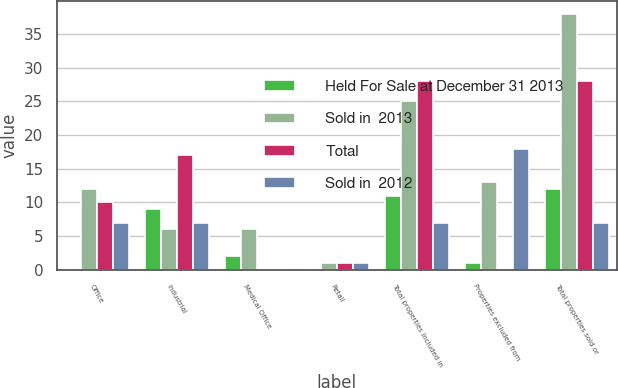Convert chart. <chart><loc_0><loc_0><loc_500><loc_500><stacked_bar_chart><ecel><fcel>Office<fcel>Industrial<fcel>Medical Office<fcel>Retail<fcel>Total properties included in<fcel>Properties excluded from<fcel>Total properties sold or<nl><fcel>Held For Sale at December 31 2013<fcel>0<fcel>9<fcel>2<fcel>0<fcel>11<fcel>1<fcel>12<nl><fcel>Sold in  2013<fcel>12<fcel>6<fcel>6<fcel>1<fcel>25<fcel>13<fcel>38<nl><fcel>Total<fcel>10<fcel>17<fcel>0<fcel>1<fcel>28<fcel>0<fcel>28<nl><fcel>Sold in  2012<fcel>7<fcel>7<fcel>0<fcel>1<fcel>7<fcel>18<fcel>7<nl></chart> 